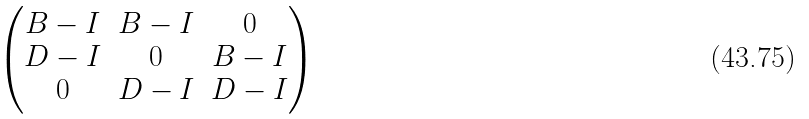Convert formula to latex. <formula><loc_0><loc_0><loc_500><loc_500>\begin{pmatrix} B - I & B - I & 0 \\ D - I & 0 & B - I \\ 0 & D - I & D - I \end{pmatrix}</formula> 